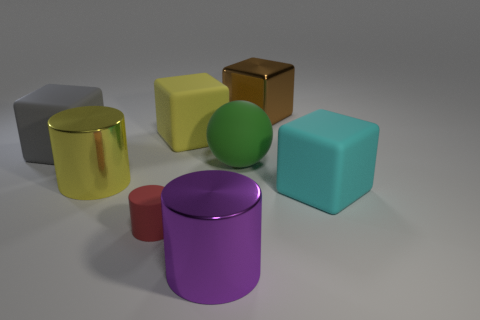How big is the metallic cube behind the big metal cylinder left of the big shiny thing in front of the small red cylinder?
Ensure brevity in your answer.  Large. How many gray cubes have the same material as the red cylinder?
Your answer should be compact. 1. What is the color of the big cylinder in front of the large rubber block that is to the right of the big rubber ball?
Your answer should be very brief. Purple. What number of objects are brown rubber balls or matte cubes in front of the matte sphere?
Offer a very short reply. 1. Are there any large metallic objects of the same color as the matte cylinder?
Keep it short and to the point. No. How many green things are spheres or tiny rubber cylinders?
Keep it short and to the point. 1. What number of other objects are the same size as the yellow metal cylinder?
Make the answer very short. 6. How many large objects are gray spheres or rubber balls?
Give a very brief answer. 1. Is the size of the cyan rubber block the same as the yellow thing that is behind the large gray matte block?
Provide a short and direct response. Yes. What number of other things are there of the same shape as the big cyan thing?
Give a very brief answer. 3. 